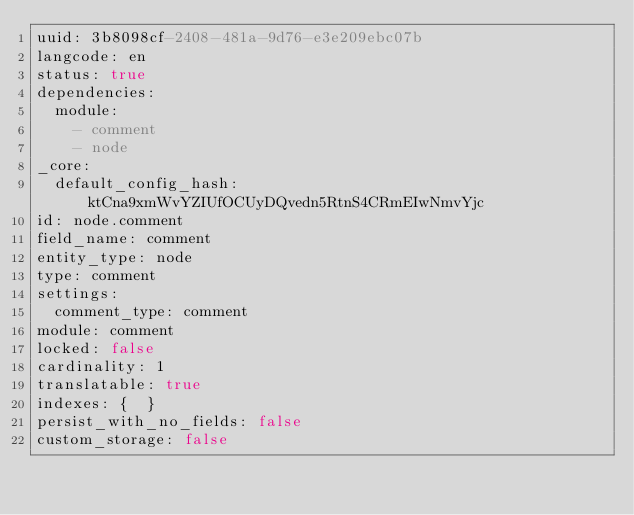Convert code to text. <code><loc_0><loc_0><loc_500><loc_500><_YAML_>uuid: 3b8098cf-2408-481a-9d76-e3e209ebc07b
langcode: en
status: true
dependencies:
  module:
    - comment
    - node
_core:
  default_config_hash: ktCna9xmWvYZIUfOCUyDQvedn5RtnS4CRmEIwNmvYjc
id: node.comment
field_name: comment
entity_type: node
type: comment
settings:
  comment_type: comment
module: comment
locked: false
cardinality: 1
translatable: true
indexes: {  }
persist_with_no_fields: false
custom_storage: false
</code> 